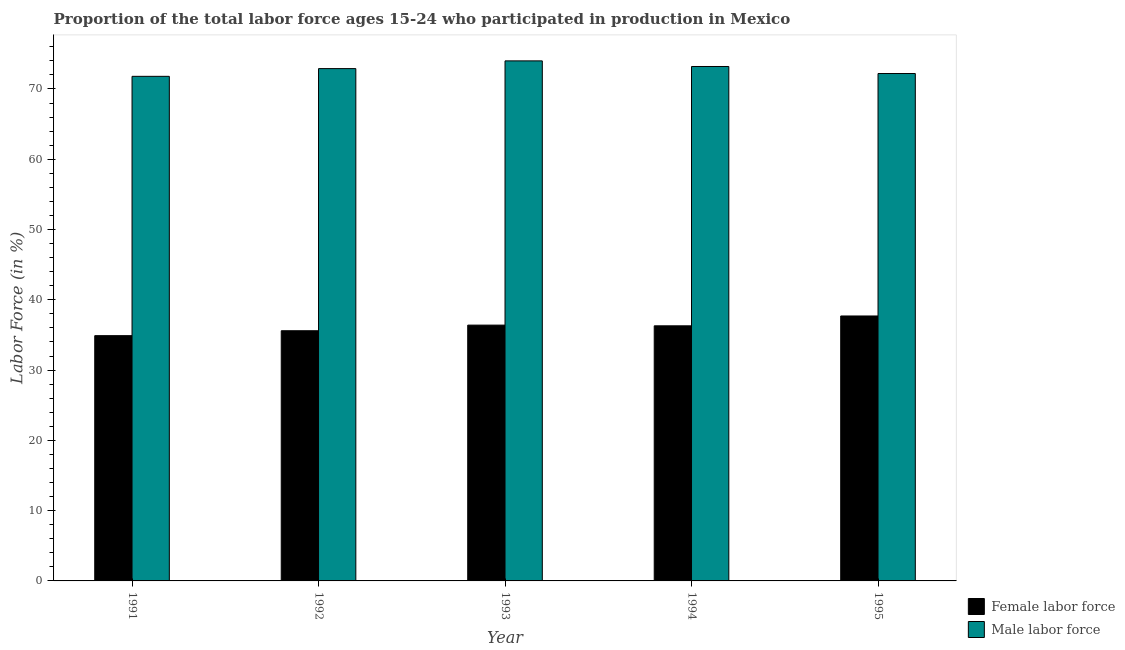Are the number of bars on each tick of the X-axis equal?
Your response must be concise. Yes. How many bars are there on the 3rd tick from the left?
Provide a short and direct response. 2. What is the label of the 2nd group of bars from the left?
Your answer should be very brief. 1992. In how many cases, is the number of bars for a given year not equal to the number of legend labels?
Ensure brevity in your answer.  0. What is the percentage of female labor force in 1992?
Keep it short and to the point. 35.6. Across all years, what is the maximum percentage of female labor force?
Provide a short and direct response. 37.7. Across all years, what is the minimum percentage of female labor force?
Provide a succinct answer. 34.9. In which year was the percentage of male labour force minimum?
Provide a short and direct response. 1991. What is the total percentage of female labor force in the graph?
Provide a succinct answer. 180.9. What is the difference between the percentage of male labour force in 1991 and that in 1993?
Provide a succinct answer. -2.2. What is the difference between the percentage of female labor force in 1993 and the percentage of male labour force in 1995?
Keep it short and to the point. -1.3. What is the average percentage of female labor force per year?
Your response must be concise. 36.18. What is the ratio of the percentage of female labor force in 1992 to that in 1994?
Your response must be concise. 0.98. Is the percentage of female labor force in 1991 less than that in 1993?
Provide a succinct answer. Yes. What is the difference between the highest and the second highest percentage of male labour force?
Give a very brief answer. 0.8. What is the difference between the highest and the lowest percentage of male labour force?
Your response must be concise. 2.2. What does the 1st bar from the left in 1991 represents?
Your response must be concise. Female labor force. What does the 2nd bar from the right in 1994 represents?
Make the answer very short. Female labor force. How many bars are there?
Your answer should be compact. 10. Are all the bars in the graph horizontal?
Give a very brief answer. No. Does the graph contain grids?
Give a very brief answer. No. Where does the legend appear in the graph?
Offer a very short reply. Bottom right. How are the legend labels stacked?
Give a very brief answer. Vertical. What is the title of the graph?
Give a very brief answer. Proportion of the total labor force ages 15-24 who participated in production in Mexico. What is the label or title of the Y-axis?
Make the answer very short. Labor Force (in %). What is the Labor Force (in %) of Female labor force in 1991?
Offer a terse response. 34.9. What is the Labor Force (in %) of Male labor force in 1991?
Make the answer very short. 71.8. What is the Labor Force (in %) of Female labor force in 1992?
Your response must be concise. 35.6. What is the Labor Force (in %) of Male labor force in 1992?
Offer a very short reply. 72.9. What is the Labor Force (in %) of Female labor force in 1993?
Your answer should be very brief. 36.4. What is the Labor Force (in %) in Male labor force in 1993?
Your response must be concise. 74. What is the Labor Force (in %) in Female labor force in 1994?
Keep it short and to the point. 36.3. What is the Labor Force (in %) in Male labor force in 1994?
Your answer should be very brief. 73.2. What is the Labor Force (in %) of Female labor force in 1995?
Provide a succinct answer. 37.7. What is the Labor Force (in %) of Male labor force in 1995?
Keep it short and to the point. 72.2. Across all years, what is the maximum Labor Force (in %) of Female labor force?
Ensure brevity in your answer.  37.7. Across all years, what is the maximum Labor Force (in %) in Male labor force?
Give a very brief answer. 74. Across all years, what is the minimum Labor Force (in %) of Female labor force?
Offer a very short reply. 34.9. Across all years, what is the minimum Labor Force (in %) of Male labor force?
Your response must be concise. 71.8. What is the total Labor Force (in %) of Female labor force in the graph?
Give a very brief answer. 180.9. What is the total Labor Force (in %) in Male labor force in the graph?
Keep it short and to the point. 364.1. What is the difference between the Labor Force (in %) in Female labor force in 1991 and that in 1992?
Your answer should be compact. -0.7. What is the difference between the Labor Force (in %) in Male labor force in 1991 and that in 1992?
Ensure brevity in your answer.  -1.1. What is the difference between the Labor Force (in %) in Female labor force in 1991 and that in 1994?
Offer a terse response. -1.4. What is the difference between the Labor Force (in %) of Male labor force in 1991 and that in 1994?
Offer a very short reply. -1.4. What is the difference between the Labor Force (in %) in Female labor force in 1991 and that in 1995?
Your answer should be compact. -2.8. What is the difference between the Labor Force (in %) in Male labor force in 1991 and that in 1995?
Make the answer very short. -0.4. What is the difference between the Labor Force (in %) of Male labor force in 1992 and that in 1993?
Offer a terse response. -1.1. What is the difference between the Labor Force (in %) of Female labor force in 1993 and that in 1995?
Your response must be concise. -1.3. What is the difference between the Labor Force (in %) in Male labor force in 1993 and that in 1995?
Give a very brief answer. 1.8. What is the difference between the Labor Force (in %) in Female labor force in 1994 and that in 1995?
Provide a short and direct response. -1.4. What is the difference between the Labor Force (in %) of Female labor force in 1991 and the Labor Force (in %) of Male labor force in 1992?
Offer a terse response. -38. What is the difference between the Labor Force (in %) of Female labor force in 1991 and the Labor Force (in %) of Male labor force in 1993?
Your answer should be very brief. -39.1. What is the difference between the Labor Force (in %) in Female labor force in 1991 and the Labor Force (in %) in Male labor force in 1994?
Ensure brevity in your answer.  -38.3. What is the difference between the Labor Force (in %) in Female labor force in 1991 and the Labor Force (in %) in Male labor force in 1995?
Your answer should be very brief. -37.3. What is the difference between the Labor Force (in %) of Female labor force in 1992 and the Labor Force (in %) of Male labor force in 1993?
Your answer should be compact. -38.4. What is the difference between the Labor Force (in %) of Female labor force in 1992 and the Labor Force (in %) of Male labor force in 1994?
Your response must be concise. -37.6. What is the difference between the Labor Force (in %) of Female labor force in 1992 and the Labor Force (in %) of Male labor force in 1995?
Provide a short and direct response. -36.6. What is the difference between the Labor Force (in %) in Female labor force in 1993 and the Labor Force (in %) in Male labor force in 1994?
Give a very brief answer. -36.8. What is the difference between the Labor Force (in %) in Female labor force in 1993 and the Labor Force (in %) in Male labor force in 1995?
Offer a very short reply. -35.8. What is the difference between the Labor Force (in %) in Female labor force in 1994 and the Labor Force (in %) in Male labor force in 1995?
Give a very brief answer. -35.9. What is the average Labor Force (in %) in Female labor force per year?
Keep it short and to the point. 36.18. What is the average Labor Force (in %) of Male labor force per year?
Provide a succinct answer. 72.82. In the year 1991, what is the difference between the Labor Force (in %) of Female labor force and Labor Force (in %) of Male labor force?
Your answer should be very brief. -36.9. In the year 1992, what is the difference between the Labor Force (in %) in Female labor force and Labor Force (in %) in Male labor force?
Keep it short and to the point. -37.3. In the year 1993, what is the difference between the Labor Force (in %) of Female labor force and Labor Force (in %) of Male labor force?
Offer a very short reply. -37.6. In the year 1994, what is the difference between the Labor Force (in %) of Female labor force and Labor Force (in %) of Male labor force?
Offer a very short reply. -36.9. In the year 1995, what is the difference between the Labor Force (in %) in Female labor force and Labor Force (in %) in Male labor force?
Provide a short and direct response. -34.5. What is the ratio of the Labor Force (in %) of Female labor force in 1991 to that in 1992?
Provide a succinct answer. 0.98. What is the ratio of the Labor Force (in %) in Male labor force in 1991 to that in 1992?
Provide a succinct answer. 0.98. What is the ratio of the Labor Force (in %) in Female labor force in 1991 to that in 1993?
Keep it short and to the point. 0.96. What is the ratio of the Labor Force (in %) of Male labor force in 1991 to that in 1993?
Offer a terse response. 0.97. What is the ratio of the Labor Force (in %) of Female labor force in 1991 to that in 1994?
Keep it short and to the point. 0.96. What is the ratio of the Labor Force (in %) in Male labor force in 1991 to that in 1994?
Offer a very short reply. 0.98. What is the ratio of the Labor Force (in %) in Female labor force in 1991 to that in 1995?
Provide a succinct answer. 0.93. What is the ratio of the Labor Force (in %) in Male labor force in 1992 to that in 1993?
Offer a very short reply. 0.99. What is the ratio of the Labor Force (in %) in Female labor force in 1992 to that in 1994?
Offer a very short reply. 0.98. What is the ratio of the Labor Force (in %) of Female labor force in 1992 to that in 1995?
Your response must be concise. 0.94. What is the ratio of the Labor Force (in %) of Male labor force in 1992 to that in 1995?
Ensure brevity in your answer.  1.01. What is the ratio of the Labor Force (in %) of Male labor force in 1993 to that in 1994?
Provide a succinct answer. 1.01. What is the ratio of the Labor Force (in %) of Female labor force in 1993 to that in 1995?
Ensure brevity in your answer.  0.97. What is the ratio of the Labor Force (in %) in Male labor force in 1993 to that in 1995?
Offer a terse response. 1.02. What is the ratio of the Labor Force (in %) in Female labor force in 1994 to that in 1995?
Your answer should be very brief. 0.96. What is the ratio of the Labor Force (in %) in Male labor force in 1994 to that in 1995?
Provide a succinct answer. 1.01. What is the difference between the highest and the second highest Labor Force (in %) in Female labor force?
Ensure brevity in your answer.  1.3. What is the difference between the highest and the lowest Labor Force (in %) in Female labor force?
Give a very brief answer. 2.8. 